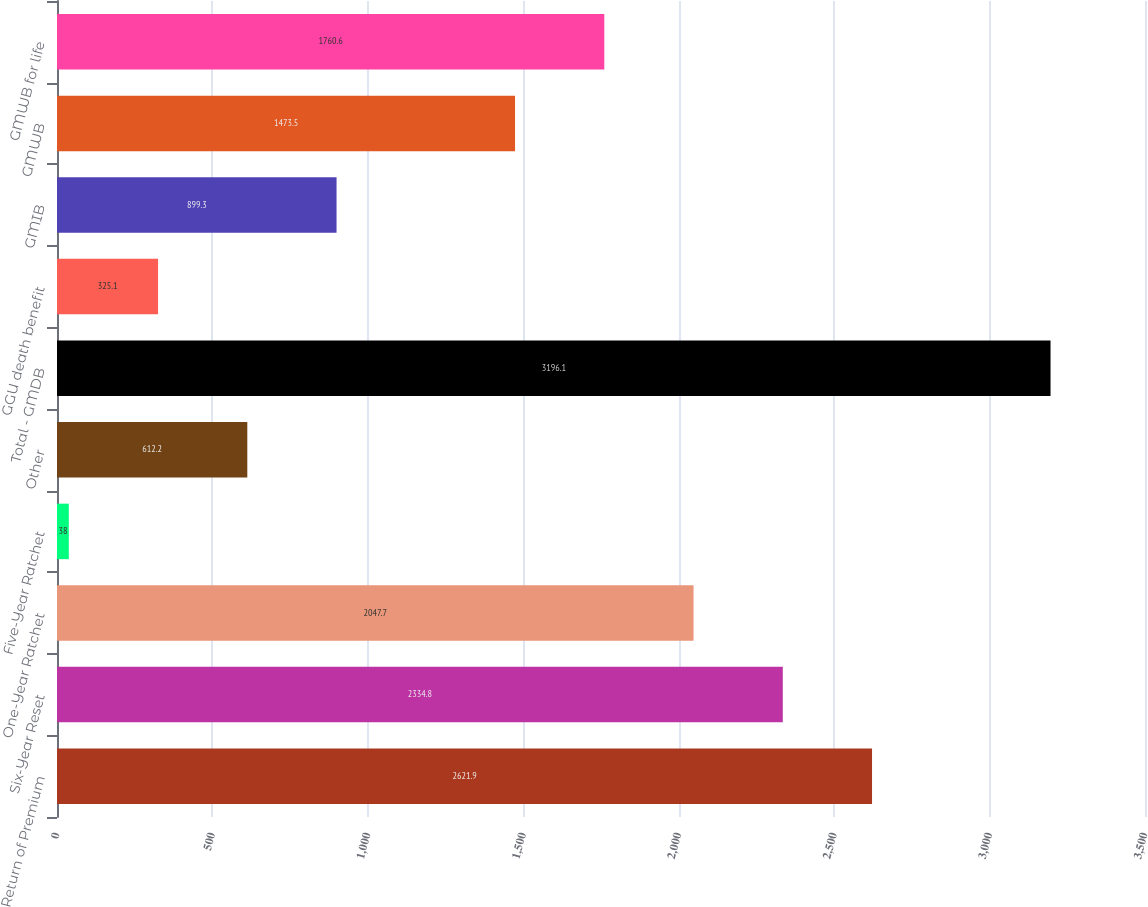<chart> <loc_0><loc_0><loc_500><loc_500><bar_chart><fcel>Return of Premium<fcel>Six-Year Reset<fcel>One-Year Ratchet<fcel>Five-Year Ratchet<fcel>Other<fcel>Total - GMDB<fcel>GGU death benefit<fcel>GMIB<fcel>GMWB<fcel>GMWB for life<nl><fcel>2621.9<fcel>2334.8<fcel>2047.7<fcel>38<fcel>612.2<fcel>3196.1<fcel>325.1<fcel>899.3<fcel>1473.5<fcel>1760.6<nl></chart> 